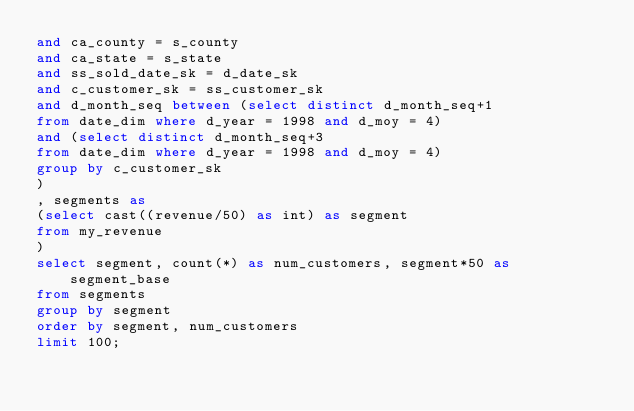<code> <loc_0><loc_0><loc_500><loc_500><_SQL_>and ca_county = s_county
and ca_state = s_state
and ss_sold_date_sk = d_date_sk
and c_customer_sk = ss_customer_sk
and d_month_seq between (select distinct d_month_seq+1
from date_dim where d_year = 1998 and d_moy = 4)
and (select distinct d_month_seq+3
from date_dim where d_year = 1998 and d_moy = 4)
group by c_customer_sk
)
, segments as
(select cast((revenue/50) as int) as segment
from my_revenue
)
select segment, count(*) as num_customers, segment*50 as segment_base
from segments
group by segment
order by segment, num_customers
limit 100;
</code> 